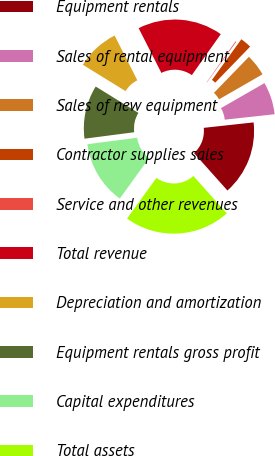Convert chart. <chart><loc_0><loc_0><loc_500><loc_500><pie_chart><fcel>Equipment rentals<fcel>Sales of rental equipment<fcel>Sales of new equipment<fcel>Contractor supplies sales<fcel>Service and other revenues<fcel>Total revenue<fcel>Depreciation and amortization<fcel>Equipment rentals gross profit<fcel>Capital expenditures<fcel>Total assets<nl><fcel>15.13%<fcel>6.58%<fcel>4.44%<fcel>2.3%<fcel>0.16%<fcel>17.27%<fcel>8.72%<fcel>10.86%<fcel>12.99%<fcel>21.55%<nl></chart> 